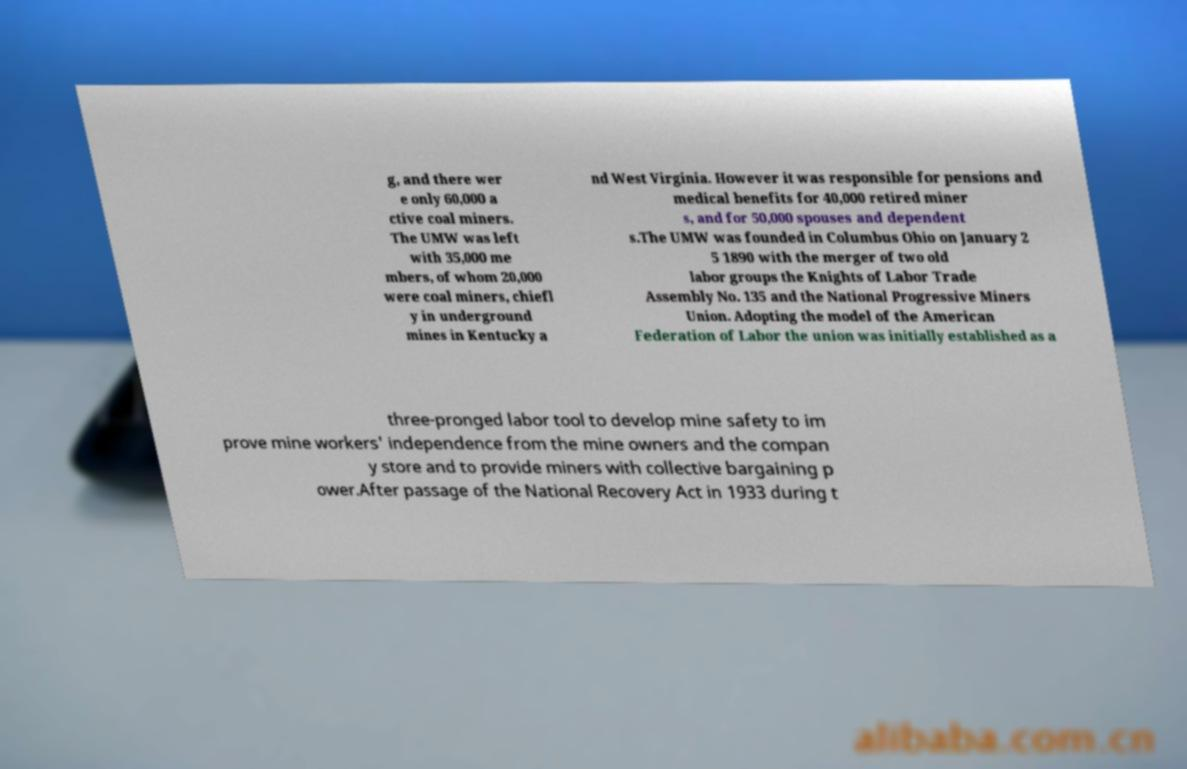For documentation purposes, I need the text within this image transcribed. Could you provide that? g, and there wer e only 60,000 a ctive coal miners. The UMW was left with 35,000 me mbers, of whom 20,000 were coal miners, chiefl y in underground mines in Kentucky a nd West Virginia. However it was responsible for pensions and medical benefits for 40,000 retired miner s, and for 50,000 spouses and dependent s.The UMW was founded in Columbus Ohio on January 2 5 1890 with the merger of two old labor groups the Knights of Labor Trade Assembly No. 135 and the National Progressive Miners Union. Adopting the model of the American Federation of Labor the union was initially established as a three-pronged labor tool to develop mine safety to im prove mine workers' independence from the mine owners and the compan y store and to provide miners with collective bargaining p ower.After passage of the National Recovery Act in 1933 during t 